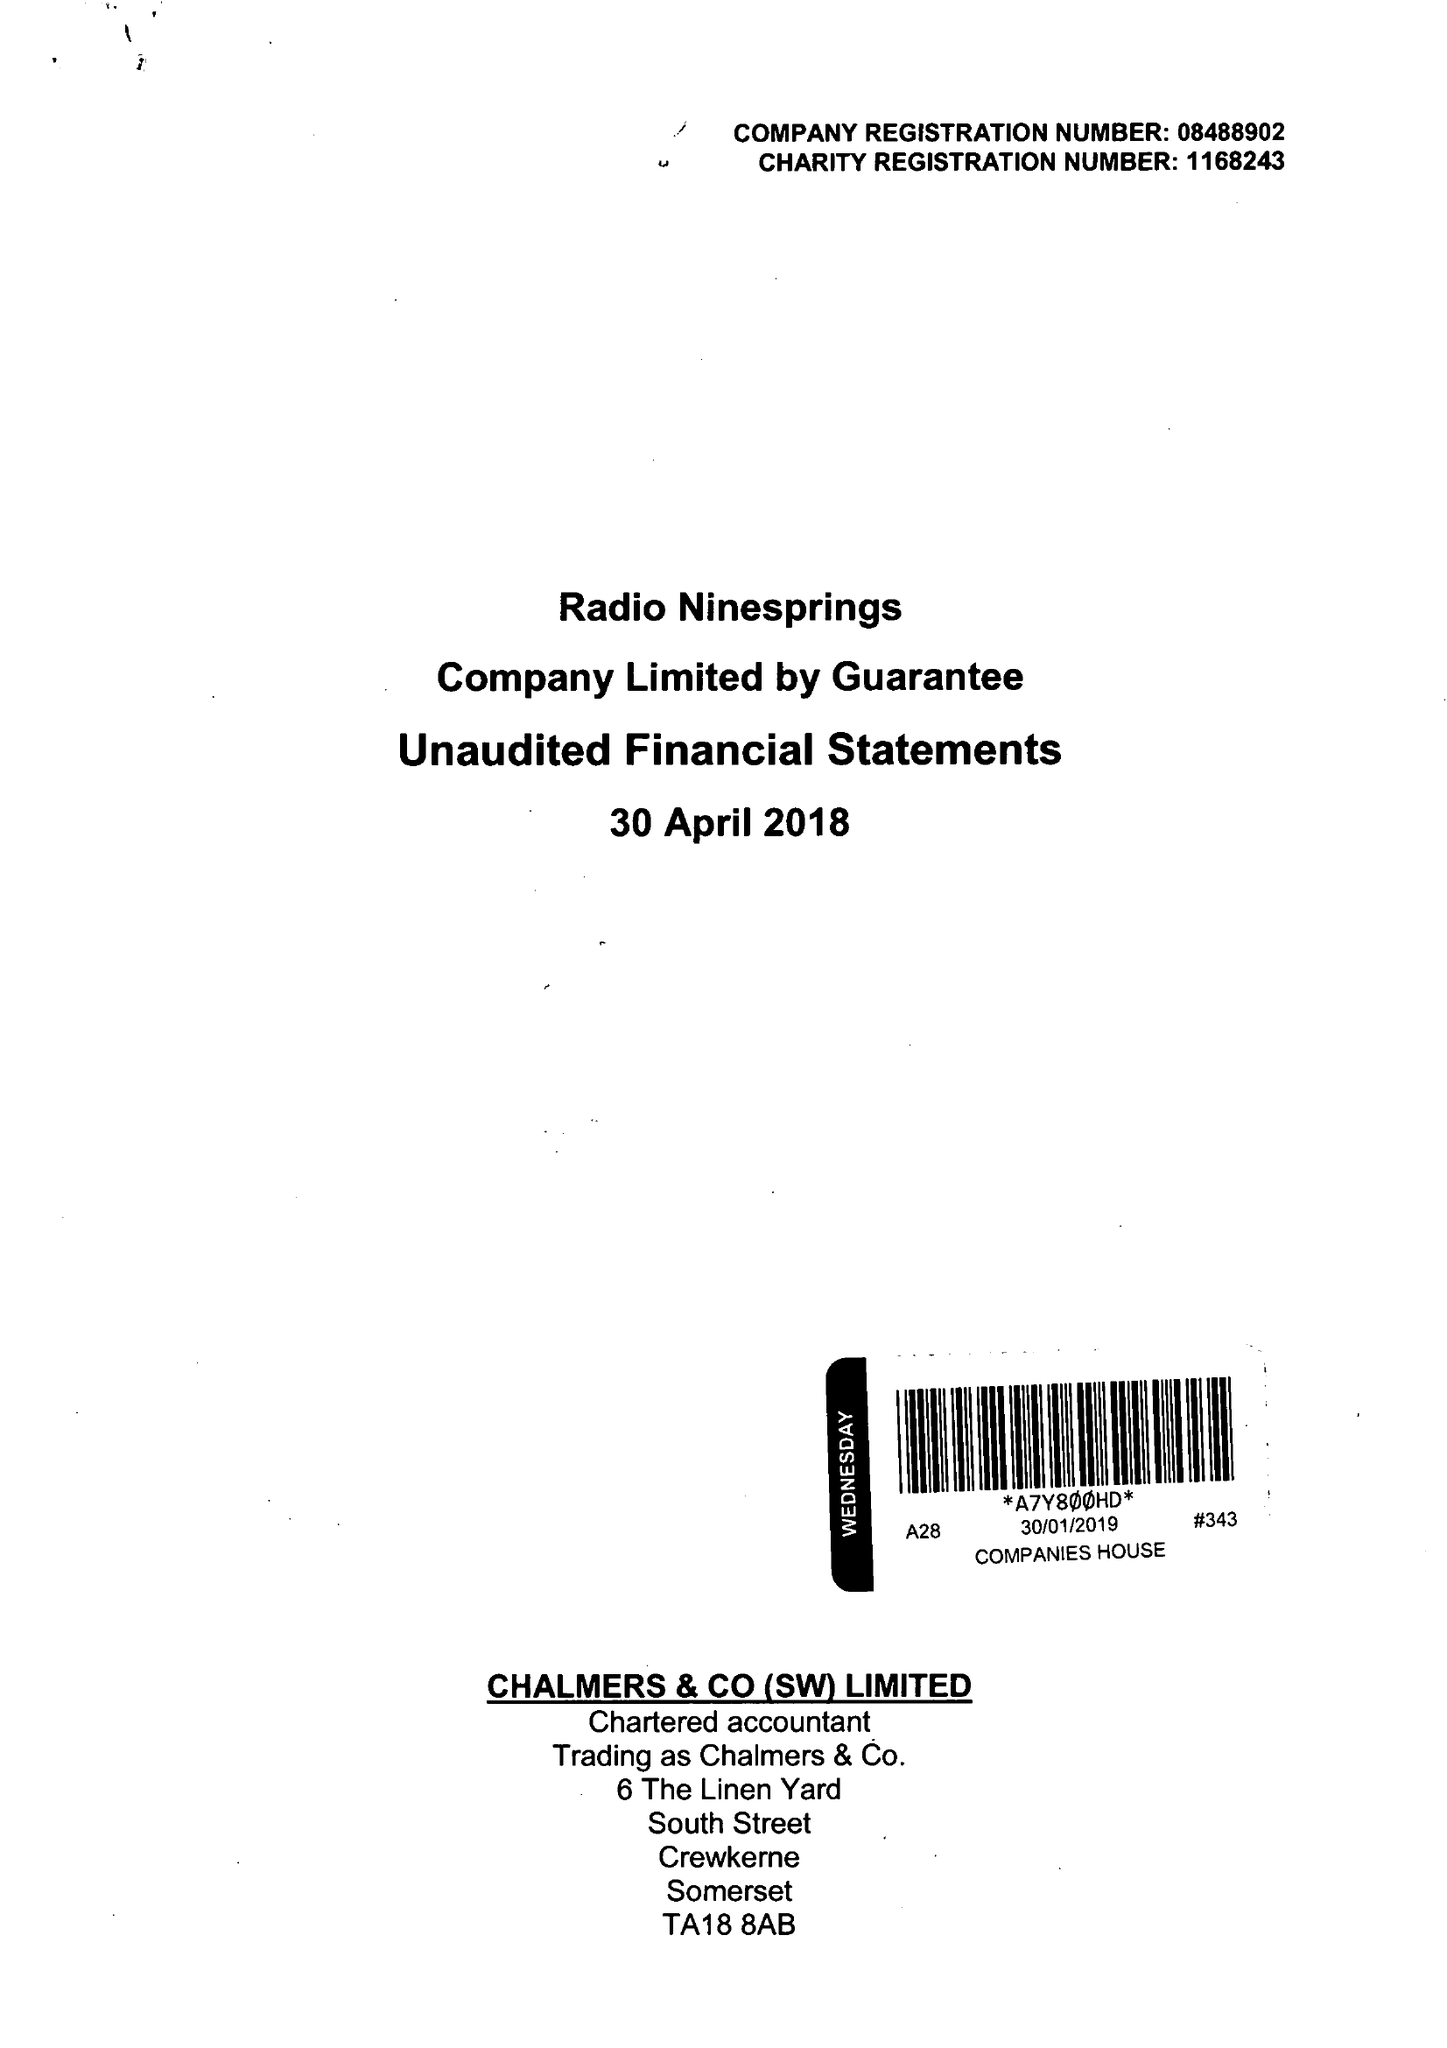What is the value for the income_annually_in_british_pounds?
Answer the question using a single word or phrase. 37798.00 